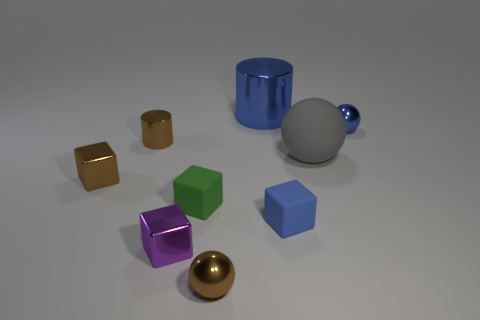Are there any tiny metal cubes that have the same color as the big rubber ball?
Provide a succinct answer. No. There is a sphere behind the gray thing; does it have the same size as the brown metal cylinder?
Provide a short and direct response. Yes. Are there fewer big purple rubber cylinders than balls?
Offer a very short reply. Yes. Are there any tiny red balls made of the same material as the gray ball?
Offer a terse response. No. What shape is the tiny object in front of the purple block?
Make the answer very short. Sphere. There is a ball on the left side of the large matte thing; does it have the same color as the large metallic object?
Your answer should be compact. No. Is the number of small purple shiny objects that are to the right of the small blue sphere less than the number of brown cylinders?
Make the answer very short. Yes. There is a big thing that is made of the same material as the brown cylinder; what color is it?
Offer a very short reply. Blue. How big is the blue object that is in front of the rubber ball?
Provide a succinct answer. Small. Is the material of the brown cylinder the same as the small blue ball?
Offer a terse response. Yes. 